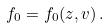Convert formula to latex. <formula><loc_0><loc_0><loc_500><loc_500>f _ { 0 } = f _ { 0 } ( z , v ) \, .</formula> 